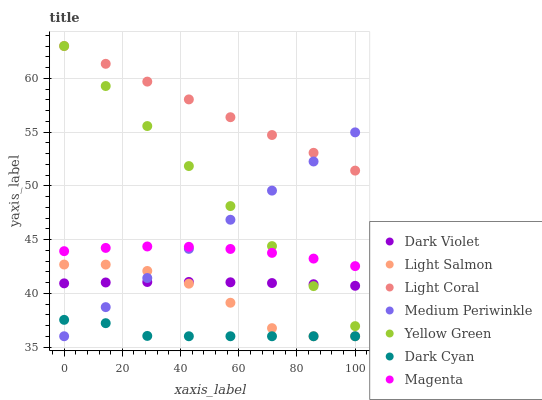Does Dark Cyan have the minimum area under the curve?
Answer yes or no. Yes. Does Light Coral have the maximum area under the curve?
Answer yes or no. Yes. Does Yellow Green have the minimum area under the curve?
Answer yes or no. No. Does Yellow Green have the maximum area under the curve?
Answer yes or no. No. Is Light Coral the smoothest?
Answer yes or no. Yes. Is Light Salmon the roughest?
Answer yes or no. Yes. Is Yellow Green the smoothest?
Answer yes or no. No. Is Yellow Green the roughest?
Answer yes or no. No. Does Light Salmon have the lowest value?
Answer yes or no. Yes. Does Yellow Green have the lowest value?
Answer yes or no. No. Does Light Coral have the highest value?
Answer yes or no. Yes. Does Medium Periwinkle have the highest value?
Answer yes or no. No. Is Light Salmon less than Yellow Green?
Answer yes or no. Yes. Is Magenta greater than Light Salmon?
Answer yes or no. Yes. Does Medium Periwinkle intersect Magenta?
Answer yes or no. Yes. Is Medium Periwinkle less than Magenta?
Answer yes or no. No. Is Medium Periwinkle greater than Magenta?
Answer yes or no. No. Does Light Salmon intersect Yellow Green?
Answer yes or no. No. 